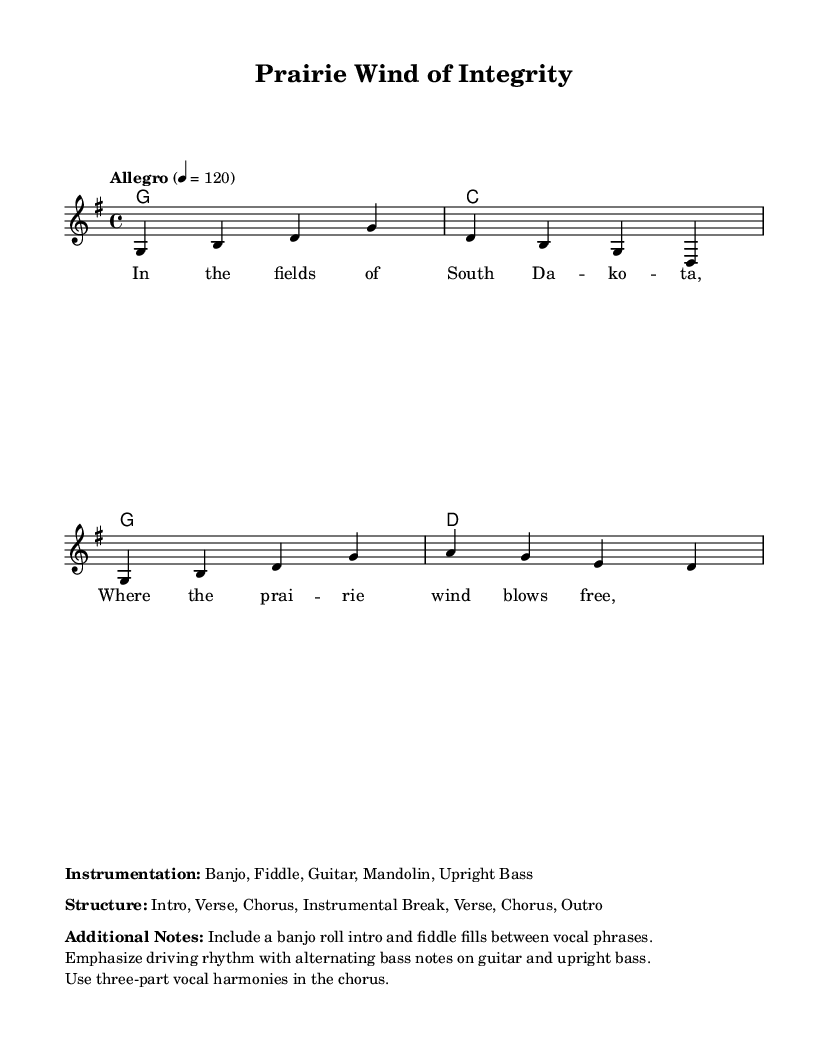What is the key signature of this music? The key signature indicated is G major, which typically has one sharp (F#). This can be identified in the global section where the command `\key g \major` is placed.
Answer: G major What is the time signature of this piece? The time signature, found in the same global section, shows `\time 4/4`, which indicates there are four beats per measure and a quarter note gets one beat.
Answer: 4/4 What is the tempo marking for this piece? The tempo marking is stated as `4 = 120`, which specifies that there are 120 beats per minute, indicated in the global section. The tempo word "Allegro" is also mentioned, suggesting a fast pace.
Answer: Allegro How many measures are in the melody? Counting the notation provided in the melody section indicates there are a total of four measures as shown by the number of bars (vertical lines) separating the notes.
Answer: Four What instruments are listed in the instrumentation? The instrumentation is provided in the markup section, where it lists the instruments used in the piece as Banjo, Fiddle, Guitar, Mandolin, and Upright Bass. These instruments are tailored to highlight the bluegrass genre.
Answer: Banjo, Fiddle, Guitar, Mandolin, Upright Bass What form does the structure of the piece take? The structure of the piece is characterized by an Intro, Verse, Chorus, Instrumental Break, Verse, Chorus, and an Outro, as described in the markup section, which outlines the arrangement of the music.
Answer: Intro, Verse, Chorus, Instrumental Break, Verse, Chorus, Outro What is the main thematic focus of the lyrics provided? The lyrics hint at themes of personal integrity and honesty, as the title "Prairie Wind of Integrity" suggests, indicating a connection with living authentically in a beautiful yet demanding environment like South Dakota.
Answer: Personal integrity and honesty 